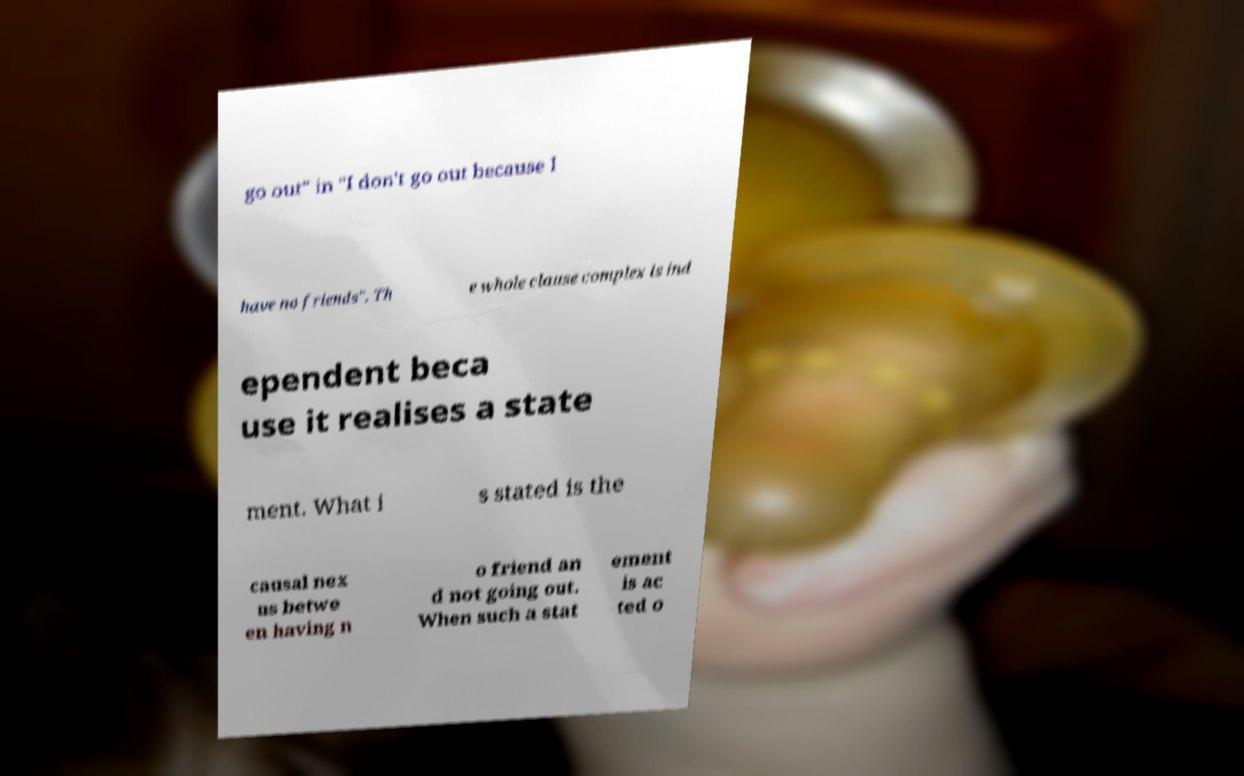Could you assist in decoding the text presented in this image and type it out clearly? go out" in "I don't go out because I have no friends". Th e whole clause complex is ind ependent beca use it realises a state ment. What i s stated is the causal nex us betwe en having n o friend an d not going out. When such a stat ement is ac ted o 